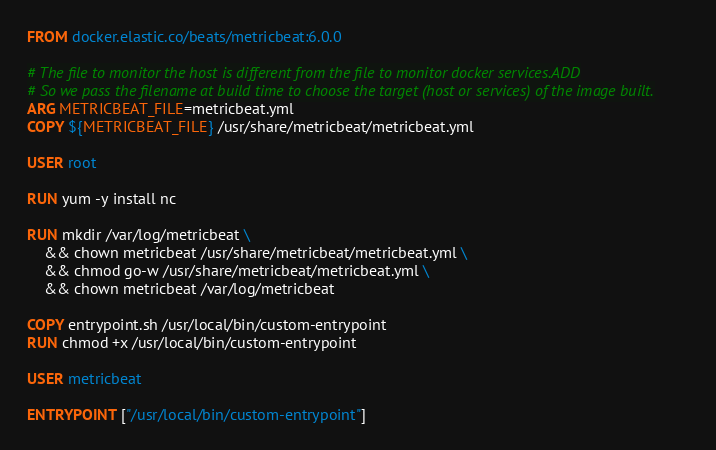Convert code to text. <code><loc_0><loc_0><loc_500><loc_500><_Dockerfile_>FROM docker.elastic.co/beats/metricbeat:6.0.0

# The file to monitor the host is different from the file to monitor docker services.ADD
# So we pass the filename at build time to choose the target (host or services) of the image built.
ARG METRICBEAT_FILE=metricbeat.yml
COPY ${METRICBEAT_FILE} /usr/share/metricbeat/metricbeat.yml

USER root

RUN yum -y install nc

RUN mkdir /var/log/metricbeat \
    && chown metricbeat /usr/share/metricbeat/metricbeat.yml \
    && chmod go-w /usr/share/metricbeat/metricbeat.yml \
    && chown metricbeat /var/log/metricbeat

COPY entrypoint.sh /usr/local/bin/custom-entrypoint
RUN chmod +x /usr/local/bin/custom-entrypoint

USER metricbeat

ENTRYPOINT ["/usr/local/bin/custom-entrypoint"]</code> 